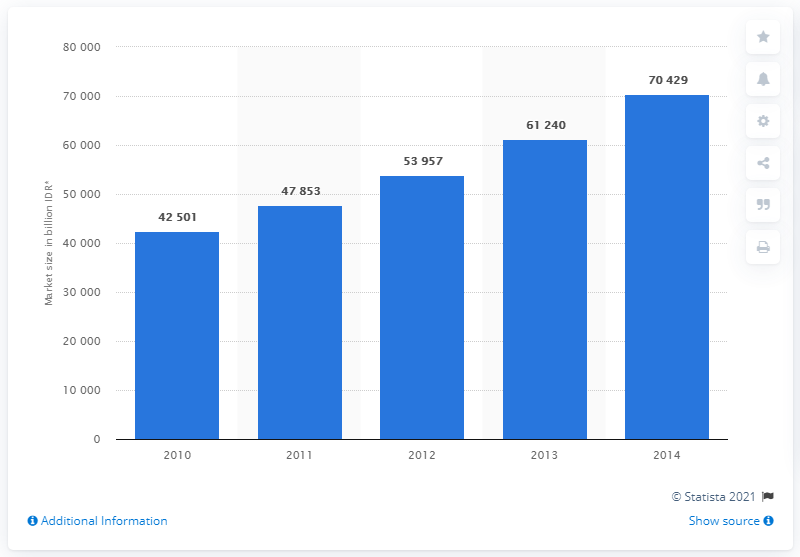Identify some key points in this picture. In 2010, the value of the Indonesian soft drink market was approximately 42,501. The sum of the median value of market sizes and its average value across all years is 109,153. In 2013, the value of the Indonesian soft drink market was approximately 61,240. The value of the rightmost bar is 70429. 